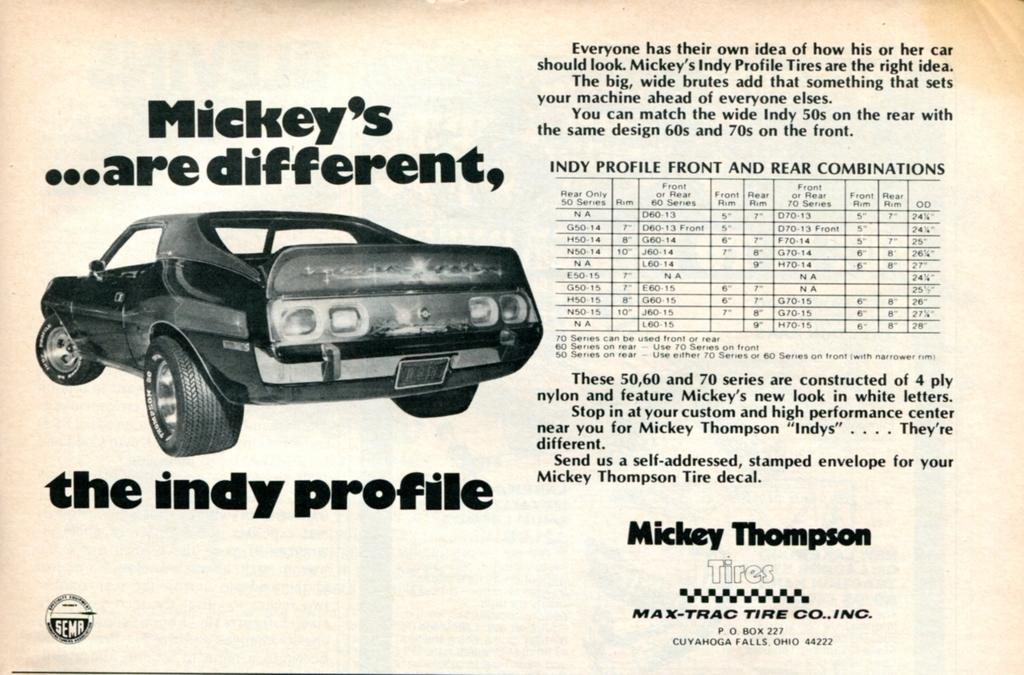What type of visual is the image? The image is a poster. What can be found on the poster besides the visual elements? There is text on the poster. Are there any additional features on the poster? Yes, there is a watermark on the poster. How many pizzas are shown on the poster? There are no pizzas present on the poster; it only contains text and a watermark. 